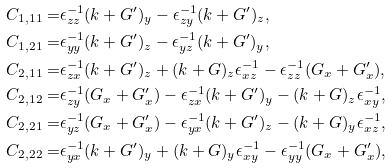<formula> <loc_0><loc_0><loc_500><loc_500>C _ { 1 , 1 1 } = & \epsilon ^ { - 1 } _ { z z } ( k + G ^ { \prime } ) _ { y } - \epsilon ^ { - 1 } _ { z y } ( k + G ^ { \prime } ) _ { z } , \\ C _ { 1 , 2 1 } = & \epsilon ^ { - 1 } _ { y y } ( k + G ^ { \prime } ) _ { z } - \epsilon ^ { - 1 } _ { y z } ( k + G ^ { \prime } ) _ { y } , \\ C _ { 2 , 1 1 } = & \epsilon ^ { - 1 } _ { z x } ( k + G ^ { \prime } ) _ { z } + ( k + G ) _ { z } \epsilon ^ { - 1 } _ { x z } - \epsilon ^ { - 1 } _ { z z } ( G _ { x } + G _ { x } ^ { \prime } ) , \\ C _ { 2 , 1 2 } = & \epsilon ^ { - 1 } _ { z y } ( G _ { x } + G _ { x } ^ { \prime } ) - \epsilon ^ { - 1 } _ { z x } ( k + G ^ { \prime } ) _ { y } - ( k + G ) _ { z } \epsilon ^ { - 1 } _ { x y } , \\ C _ { 2 , 2 1 } = & \epsilon ^ { - 1 } _ { y z } ( G _ { x } + G _ { x } ^ { \prime } ) - \epsilon ^ { - 1 } _ { y x } ( k + G ^ { \prime } ) _ { z } - ( k + G ) _ { y } \epsilon ^ { - 1 } _ { x z } , \\ C _ { 2 , 2 2 } = & \epsilon ^ { - 1 } _ { y x } ( k + G ^ { \prime } ) _ { y } + ( k + G ) _ { y } \epsilon ^ { - 1 } _ { x y } - \epsilon ^ { - 1 } _ { y y } ( G _ { x } + G _ { x } ^ { \prime } ) ,</formula> 